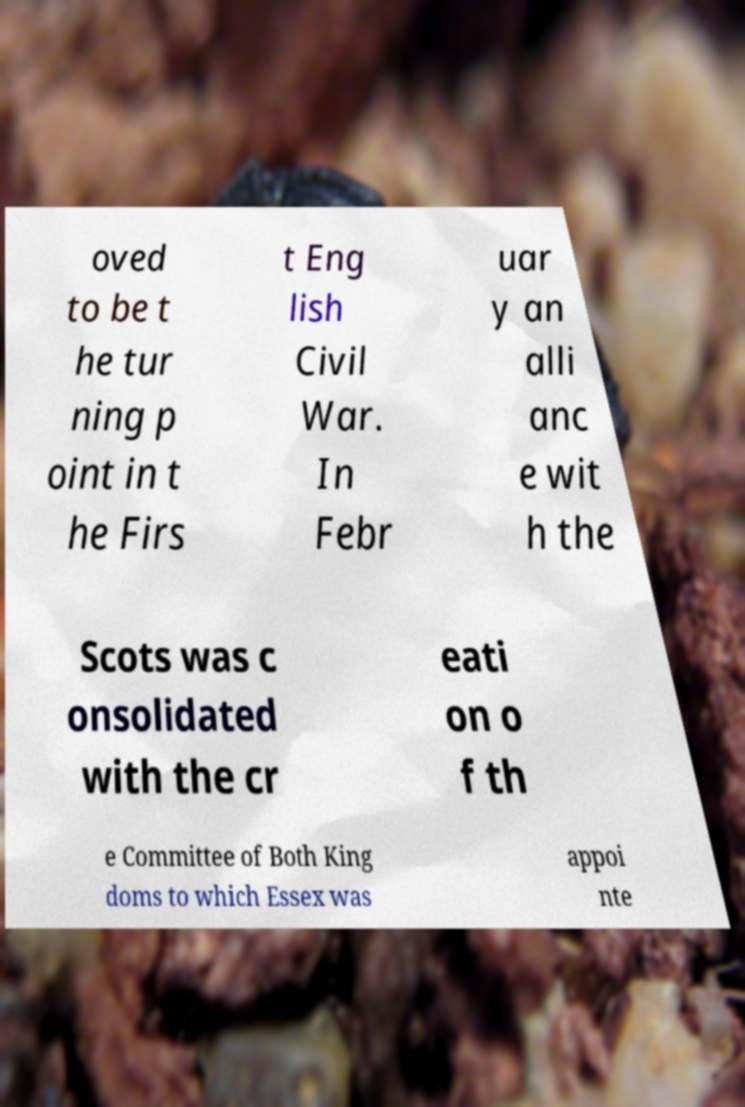What messages or text are displayed in this image? I need them in a readable, typed format. oved to be t he tur ning p oint in t he Firs t Eng lish Civil War. In Febr uar y an alli anc e wit h the Scots was c onsolidated with the cr eati on o f th e Committee of Both King doms to which Essex was appoi nte 